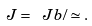<formula> <loc_0><loc_0><loc_500><loc_500>\ J = \ J b / \simeq .</formula> 